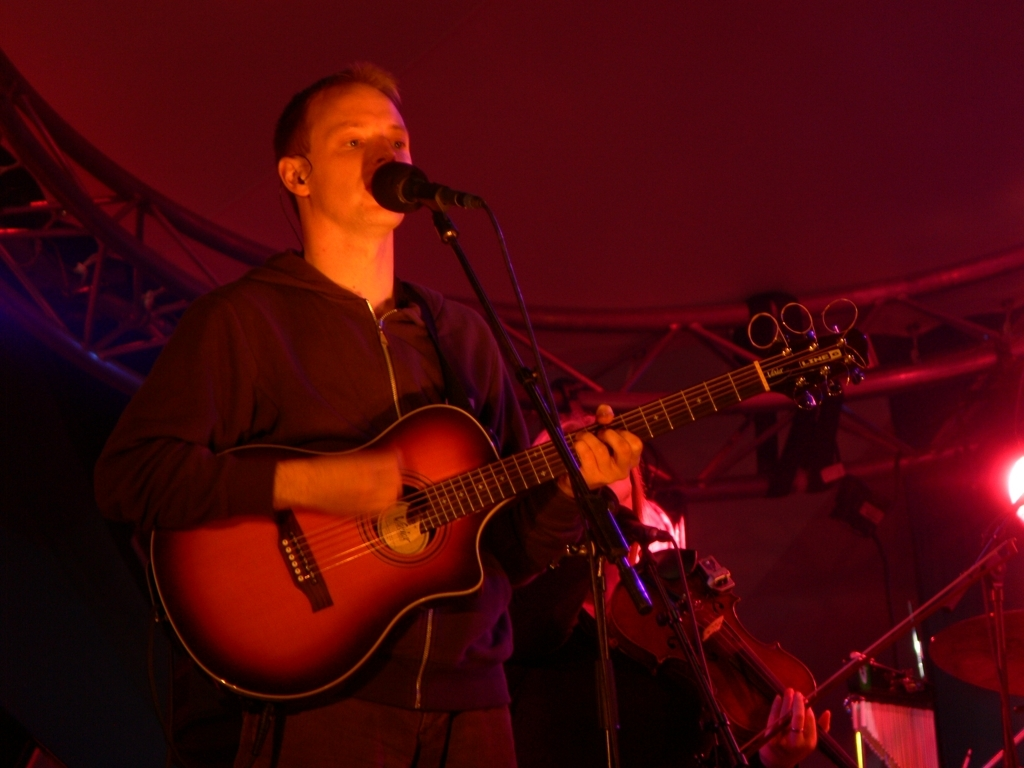What is the possible genre of music the artist could be playing? Considering the acoustic guitar in use and the solo performance setup, the artist might be playing a genre in the realm of folk, singer-songwriter, or acoustic rock. These genres often prioritize storytelling and personal expression, aligned with the artist's expressive demeanor. 